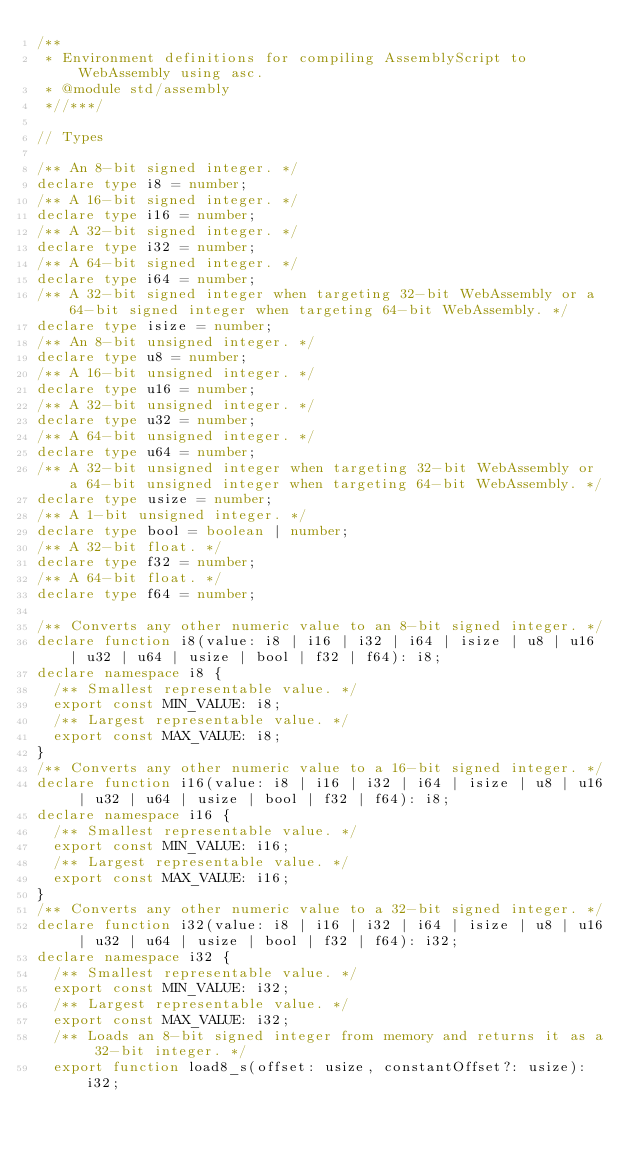Convert code to text. <code><loc_0><loc_0><loc_500><loc_500><_TypeScript_>/**
 * Environment definitions for compiling AssemblyScript to WebAssembly using asc.
 * @module std/assembly
 *//***/

// Types

/** An 8-bit signed integer. */
declare type i8 = number;
/** A 16-bit signed integer. */
declare type i16 = number;
/** A 32-bit signed integer. */
declare type i32 = number;
/** A 64-bit signed integer. */
declare type i64 = number;
/** A 32-bit signed integer when targeting 32-bit WebAssembly or a 64-bit signed integer when targeting 64-bit WebAssembly. */
declare type isize = number;
/** An 8-bit unsigned integer. */
declare type u8 = number;
/** A 16-bit unsigned integer. */
declare type u16 = number;
/** A 32-bit unsigned integer. */
declare type u32 = number;
/** A 64-bit unsigned integer. */
declare type u64 = number;
/** A 32-bit unsigned integer when targeting 32-bit WebAssembly or a 64-bit unsigned integer when targeting 64-bit WebAssembly. */
declare type usize = number;
/** A 1-bit unsigned integer. */
declare type bool = boolean | number;
/** A 32-bit float. */
declare type f32 = number;
/** A 64-bit float. */
declare type f64 = number;

/** Converts any other numeric value to an 8-bit signed integer. */
declare function i8(value: i8 | i16 | i32 | i64 | isize | u8 | u16 | u32 | u64 | usize | bool | f32 | f64): i8;
declare namespace i8 {
  /** Smallest representable value. */
  export const MIN_VALUE: i8;
  /** Largest representable value. */
  export const MAX_VALUE: i8;
}
/** Converts any other numeric value to a 16-bit signed integer. */
declare function i16(value: i8 | i16 | i32 | i64 | isize | u8 | u16 | u32 | u64 | usize | bool | f32 | f64): i8;
declare namespace i16 {
  /** Smallest representable value. */
  export const MIN_VALUE: i16;
  /** Largest representable value. */
  export const MAX_VALUE: i16;
}
/** Converts any other numeric value to a 32-bit signed integer. */
declare function i32(value: i8 | i16 | i32 | i64 | isize | u8 | u16 | u32 | u64 | usize | bool | f32 | f64): i32;
declare namespace i32 {
  /** Smallest representable value. */
  export const MIN_VALUE: i32;
  /** Largest representable value. */
  export const MAX_VALUE: i32;
  /** Loads an 8-bit signed integer from memory and returns it as a 32-bit integer. */
  export function load8_s(offset: usize, constantOffset?: usize): i32;</code> 